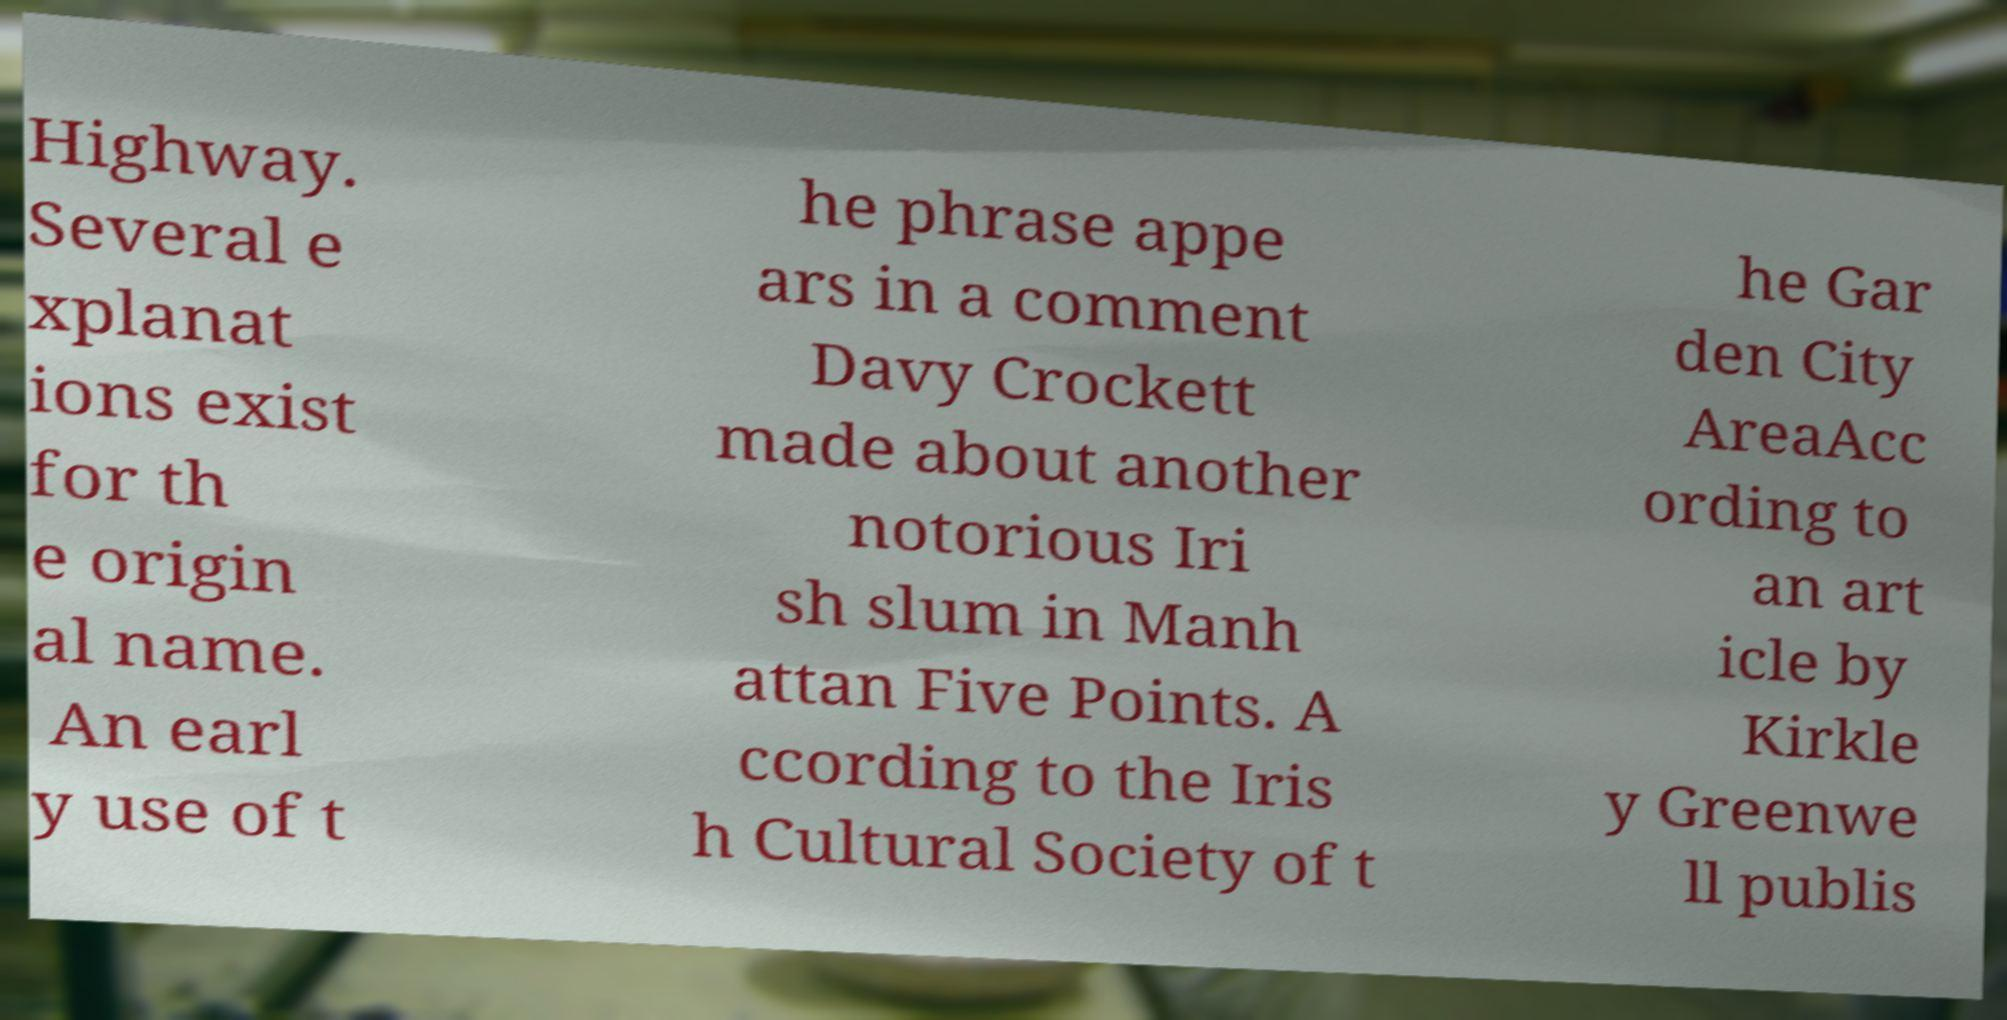Can you accurately transcribe the text from the provided image for me? Highway. Several e xplanat ions exist for th e origin al name. An earl y use of t he phrase appe ars in a comment Davy Crockett made about another notorious Iri sh slum in Manh attan Five Points. A ccording to the Iris h Cultural Society of t he Gar den City AreaAcc ording to an art icle by Kirkle y Greenwe ll publis 